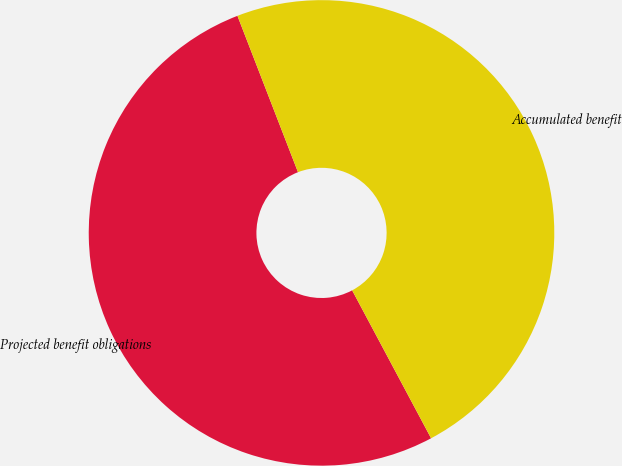<chart> <loc_0><loc_0><loc_500><loc_500><pie_chart><fcel>Projected benefit obligations<fcel>Accumulated benefit<nl><fcel>51.92%<fcel>48.08%<nl></chart> 